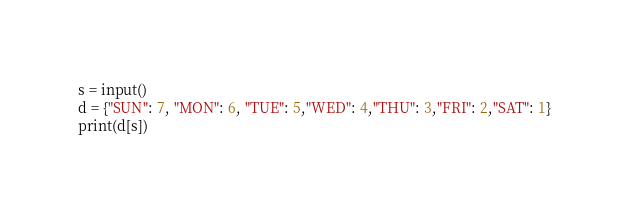Convert code to text. <code><loc_0><loc_0><loc_500><loc_500><_Python_>s = input()
d = {"SUN": 7, "MON": 6, "TUE": 5,"WED": 4,"THU": 3,"FRI": 2,"SAT": 1}
print(d[s])</code> 